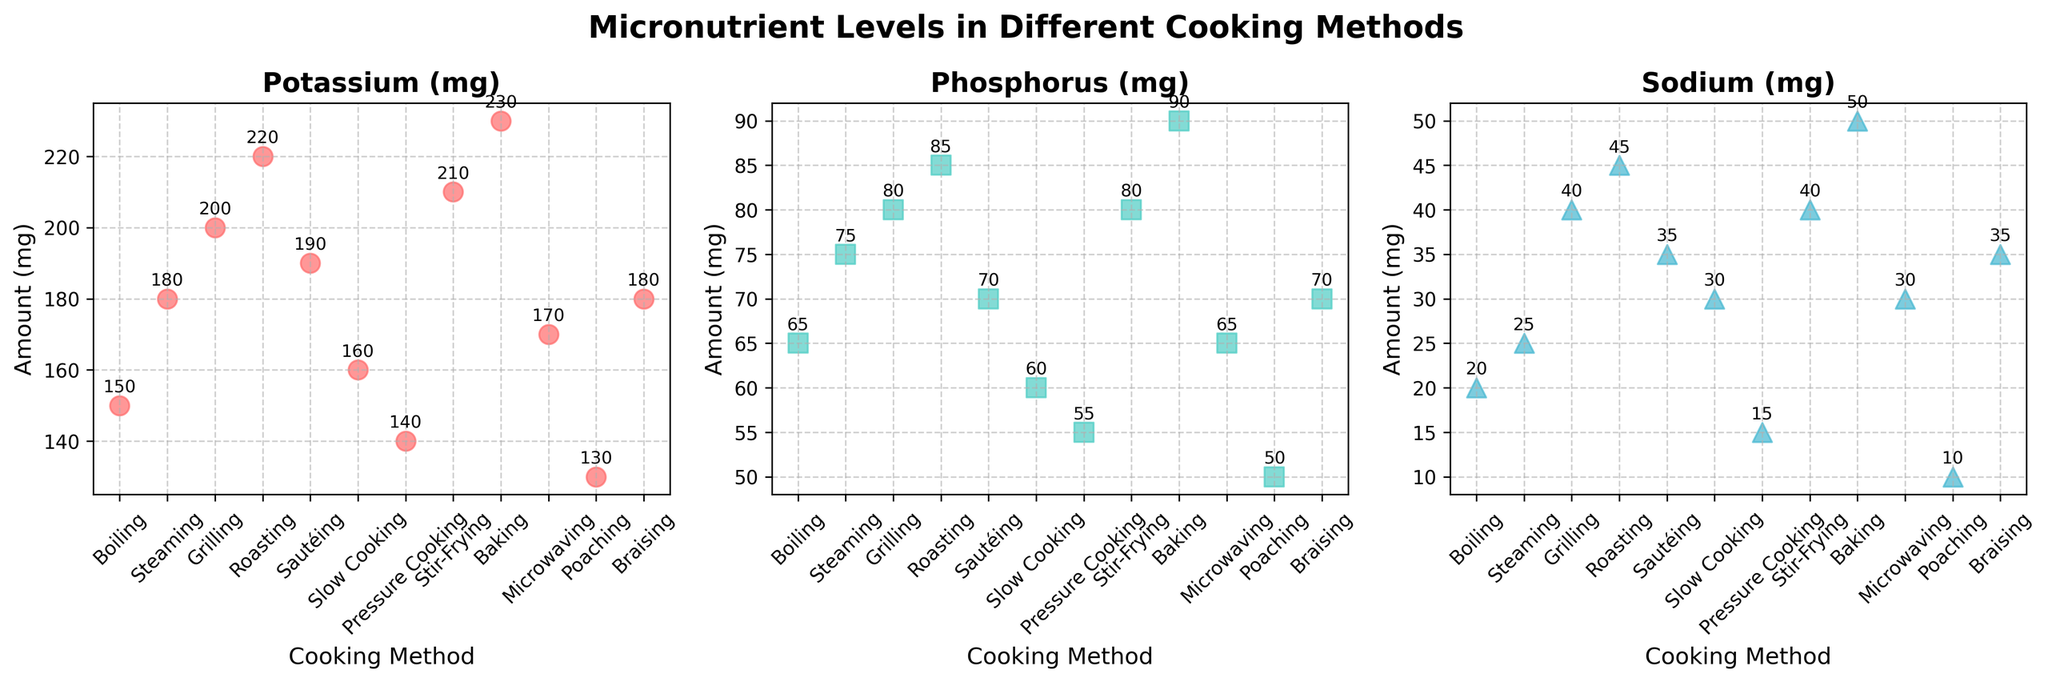What is the highest amount of Potassium (mg) found in a cooking method? The scatter plot for Potassium (mg) shows that the baking method has the highest value.
Answer: 230 mg Which cooking method results in the lowest amount of Sodium (mg)? By examining the scatter plot for Sodium (mg), poaching results in the lowest amount of Sodium at 10 mg.
Answer: Poaching What are the Potassium (mg) levels for boiling and steaming compared to each other? The scatter plot for Potassium (mg) shows that boiling has 150 mg while steaming has 180 mg.
Answer: Boiling: 150 mg, Steaming: 180 mg Which cooking method provides the second lowest value for Phosphorus (mg)? In the scatter plot for Phosphorus (mg), the poaching method has the lowest at 50 mg, and the second lowest is pressure cooking at 55 mg.
Answer: Pressure Cooking Can you find the difference in Sodium (mg) levels between roasting and sautéing? The scatter plot for Sodium (mg) shows that roasting has 45 mg and sautéing has 35 mg, so the difference is 10 mg.
Answer: 10 mg Which cooking methods have both Phosphorus (mg) and Sodium (mg) levels equal to or higher than 80 mg and 40 mg respectively? The scatter plots for both nutrients (Phosphorus and Sodium) show that grilling, stir-frying, and baking meet these criteria.
Answer: Grilling, Stir-Frying, Baking What is the average Phosphorus (mg) level across all cooking methods? Sum all the Phosphorus (mg) values: 65 + 75 + 80 + 85 + 70 + 60 + 55 + 80 + 90 + 65 + 50 + 70 = 845. There are 12 cooking methods, so the average is 845/12 = 70.42 mg.
Answer: 70.42 mg Which cooking method stands out the most in terms of Potassium (mg) concentration? In the scatter plot for Potassium (mg), baking stands out with the highest concentration at 230 mg.
Answer: Baking How much more Sodium (mg) does baking have compared to microwaving? The scatter plot for Sodium (mg) shows that baking has 50 mg of sodium, while microwaving has 30 mg, so the difference is 20 mg.
Answer: 20 mg Identify a cooking method that has higher Phosphorus (mg) levels than boiling but lower Sodium (mg) levels than grilling. Boiling has 65 mg of Phosphorus and 20 mg of Sodium. Grilling has 80 mg of Sodium. Slow cooking has 60 mg of Sodium and 60 mg of Phosphorus, which fits the criteria.
Answer: Slow Cooking 